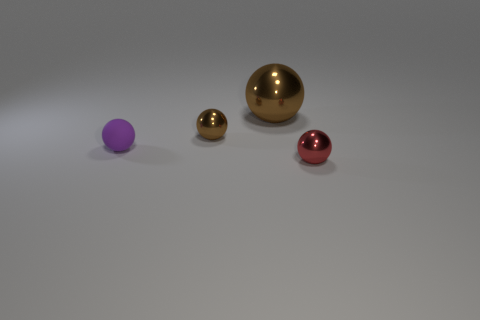There is a tiny thing that is the same color as the big metallic object; what material is it?
Keep it short and to the point. Metal. What shape is the metal object that is behind the red shiny thing and in front of the large brown thing?
Ensure brevity in your answer.  Sphere. There is a big ball that is the same material as the tiny brown ball; what color is it?
Make the answer very short. Brown. Is the number of red balls that are left of the large shiny thing the same as the number of rubber objects?
Your answer should be compact. No. What is the shape of the other brown object that is the same size as the rubber thing?
Your answer should be compact. Sphere. Does the red ball have the same size as the sphere that is behind the small brown metallic ball?
Give a very brief answer. No. What number of things are tiny balls behind the tiny purple thing or green things?
Your answer should be very brief. 1. There is a tiny thing that is behind the matte object; what is its shape?
Offer a very short reply. Sphere. Are there the same number of big spheres that are in front of the purple rubber ball and brown things left of the large object?
Make the answer very short. No. What is the color of the tiny object that is both in front of the tiny brown sphere and on the right side of the purple rubber thing?
Provide a succinct answer. Red. 